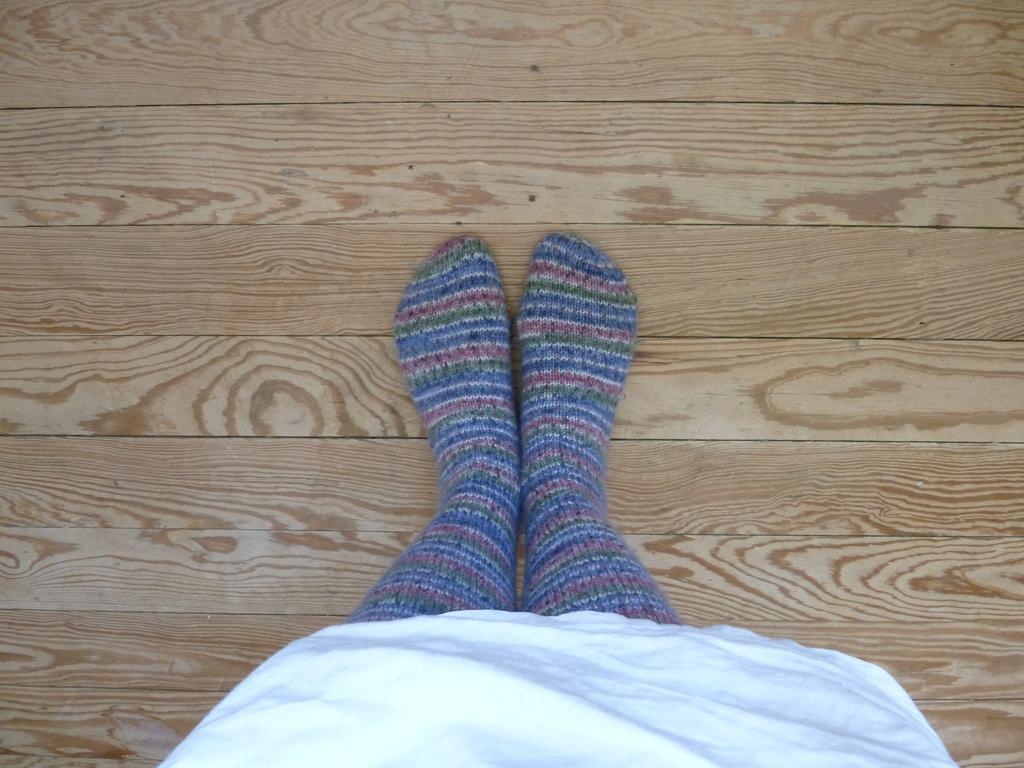Could you give a brief overview of what you see in this image? In this picture we can see a person wore socks and kept legs on a wooden platform. 